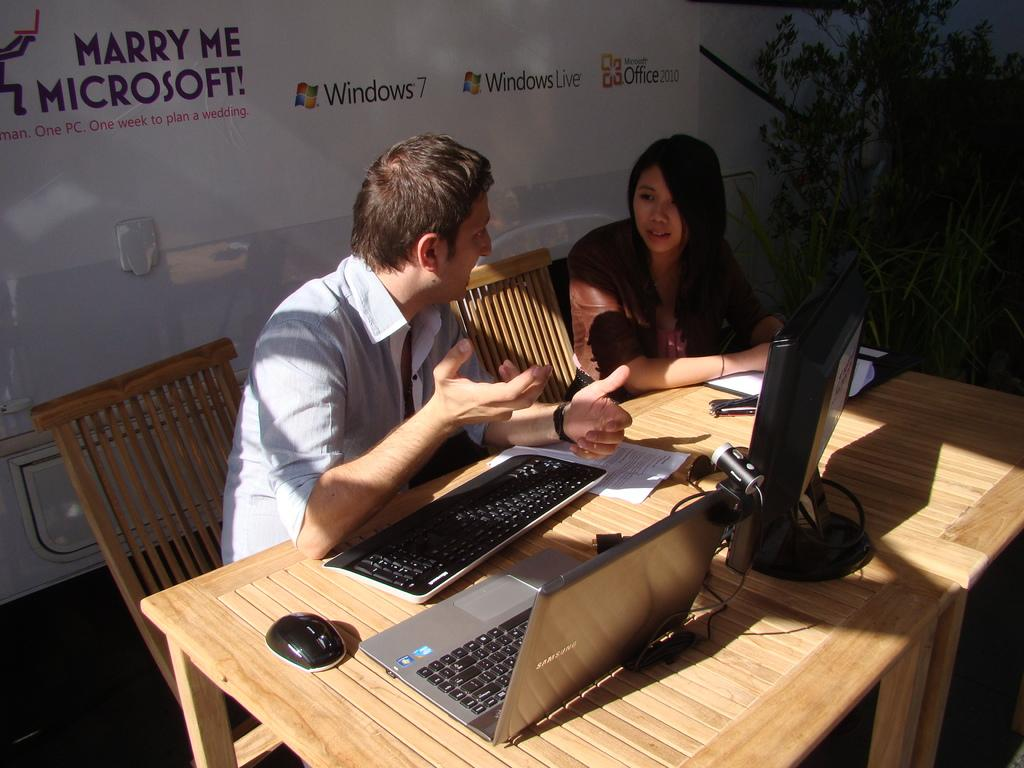How many people are in the image? There are two people in the image, a man and a woman. What are the man and woman doing in the image? The man and woman are sitting beside each other and talking. What is on the table in the image? There is a computer and a laptop on the table. Can you describe the position of the man and woman in relation to the table? The man and woman are sitting beside each other, and the table is likely between them. What type of clam can be seen on the laptop in the image? There is no clam present on the laptop or anywhere else in the image. What sound can be heard from the thunder in the image? There is no thunder present in the image, so no sound can be heard from it. 